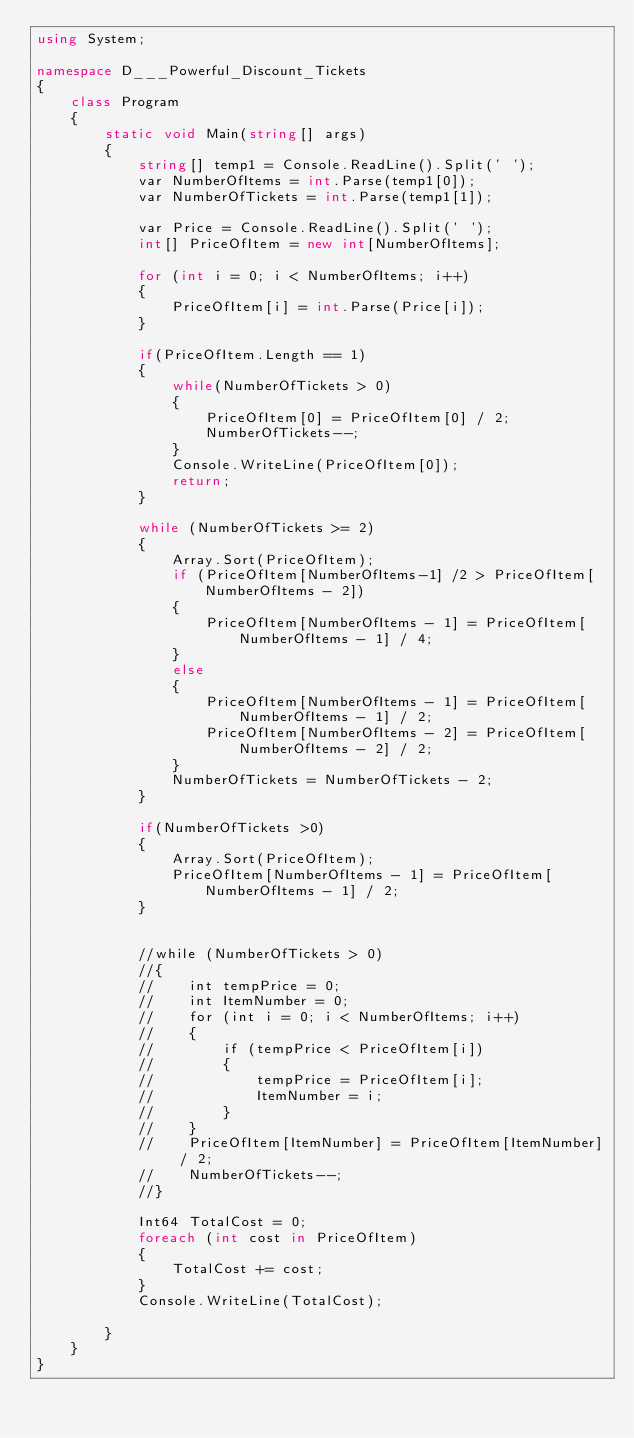<code> <loc_0><loc_0><loc_500><loc_500><_C#_>using System;

namespace D___Powerful_Discount_Tickets
{
    class Program
    {
        static void Main(string[] args)
        {
            string[] temp1 = Console.ReadLine().Split(' ');
            var NumberOfItems = int.Parse(temp1[0]);
            var NumberOfTickets = int.Parse(temp1[1]);

            var Price = Console.ReadLine().Split(' ');
            int[] PriceOfItem = new int[NumberOfItems];

            for (int i = 0; i < NumberOfItems; i++)
            {
                PriceOfItem[i] = int.Parse(Price[i]);
            }

            if(PriceOfItem.Length == 1)
            {
                while(NumberOfTickets > 0)
                {
                    PriceOfItem[0] = PriceOfItem[0] / 2;
                    NumberOfTickets--;
                }
                Console.WriteLine(PriceOfItem[0]);
                return;
            }

            while (NumberOfTickets >= 2)
            {
                Array.Sort(PriceOfItem);
                if (PriceOfItem[NumberOfItems-1] /2 > PriceOfItem[NumberOfItems - 2])
                {
                    PriceOfItem[NumberOfItems - 1] = PriceOfItem[NumberOfItems - 1] / 4;
                }
                else
                {
                    PriceOfItem[NumberOfItems - 1] = PriceOfItem[NumberOfItems - 1] / 2;
                    PriceOfItem[NumberOfItems - 2] = PriceOfItem[NumberOfItems - 2] / 2;
                }
                NumberOfTickets = NumberOfTickets - 2;
            }

            if(NumberOfTickets >0)
            {
                Array.Sort(PriceOfItem);
                PriceOfItem[NumberOfItems - 1] = PriceOfItem[NumberOfItems - 1] / 2;
            }


            //while (NumberOfTickets > 0)
            //{
            //    int tempPrice = 0;
            //    int ItemNumber = 0;
            //    for (int i = 0; i < NumberOfItems; i++)
            //    {
            //        if (tempPrice < PriceOfItem[i])
            //        {
            //            tempPrice = PriceOfItem[i];
            //            ItemNumber = i;
            //        }
            //    }
            //    PriceOfItem[ItemNumber] = PriceOfItem[ItemNumber] / 2;
            //    NumberOfTickets--;
            //}

            Int64 TotalCost = 0;
            foreach (int cost in PriceOfItem)
            {
                TotalCost += cost;
            }
            Console.WriteLine(TotalCost);

        }
    }
}
</code> 